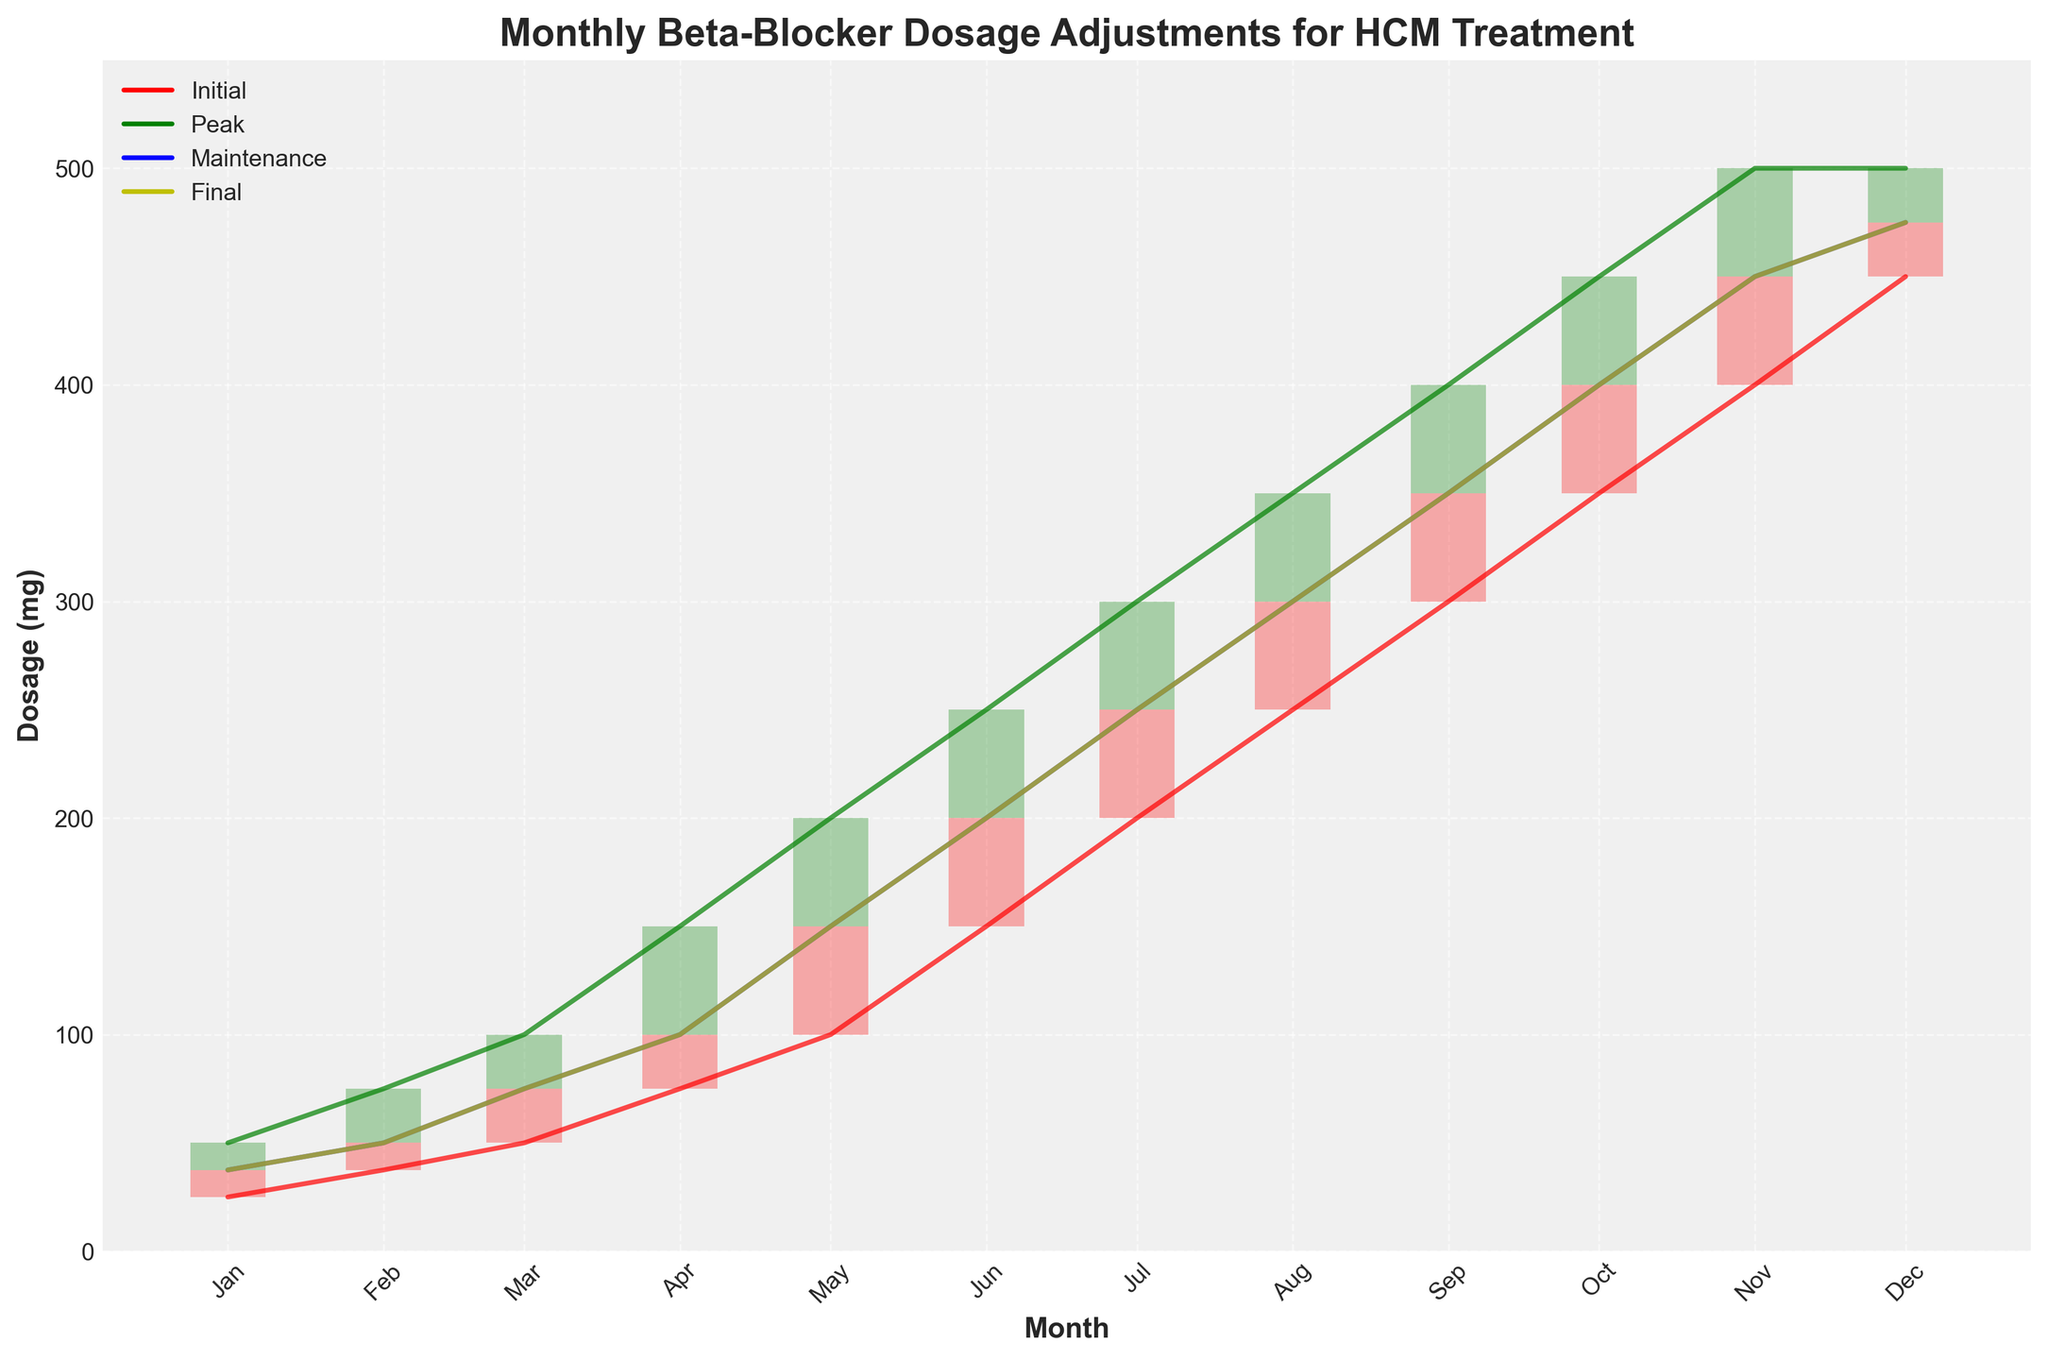How many different dosage levels are represented in the chart? The chart shows four different dosage levels which are Initial, Peak, Maintenance, and Final. This can be identified by the different colored lines and bars in the figure along with the legend that labels these categories.
Answer: Four Which month shows the highest Peak dosage? By looking at the green line or the highest green bar, it is evident that December has the highest Peak dosage value of 500 mg.
Answer: December Are there any months where the Initial dosage is higher than the Final dosage? Comparing the red and yellow lines, you can see that for all months, the Initial dosage is never higher than the Final dosage as both lines either overlap or the yellow line is above the red one.
Answer: No What is the difference between Peak and Maintenance dosages in May? In the month of May, the Peak dosage is 200 mg and the Maintenance dosage is 150 mg. The difference can be calculated as 200 - 150.
Answer: 50 mg Which month had the largest increase in Final dosage from the previous month? By comparing the Final dosage values (yellow line) month by month, the largest increase is from April to May, where it increased by 50 mg (100 mg to 150 mg).
Answer: May What is the average Peak dosage over the year? To find the average Peak dosage, sum all the Peak dosages from January to December and divide by 12. The sum is 50 + 75 + 100 + 150 + 200 + 250 + 300 + 350 + 400 + 450 + 500 + 500 = 3325. The average is 3325 / 12.
Answer: 276.04 mg How does the Maintenance dosage in July compare to the Initial dosage in the same month? In July, the Maintenance dosage (blue line) is 250 mg, whereas the Initial dosage (red line) is 200 mg, indicating that the Maintenance dosage is higher.
Answer: Maintenance dosage is higher Did the Peak dosage ever decrease in any month over the year? Examining the green line, the Peak dosage consistently rises or maintains the same in some months and does not decrease throughout the year.
Answer: No What is the total Final dosage increase from January to December? The Final dosage in January is 37.5 mg, and in December it is 475 mg. The total increase can be calculated as 475 - 37.5.
Answer: 437.5 mg In which months are the Maintenance and Final dosages the same? By comparing the blue and yellow lines, it's clear that from January through April and from November to December, the Maintenance and Final dosages are the same. These months are January, February, March, April, November, and December.
Answer: January, February, March, April, November, December 